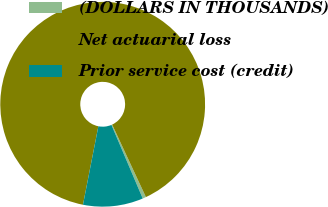Convert chart. <chart><loc_0><loc_0><loc_500><loc_500><pie_chart><fcel>(DOLLARS IN THOUSANDS)<fcel>Net actuarial loss<fcel>Prior service cost (credit)<nl><fcel>0.54%<fcel>89.98%<fcel>9.48%<nl></chart> 